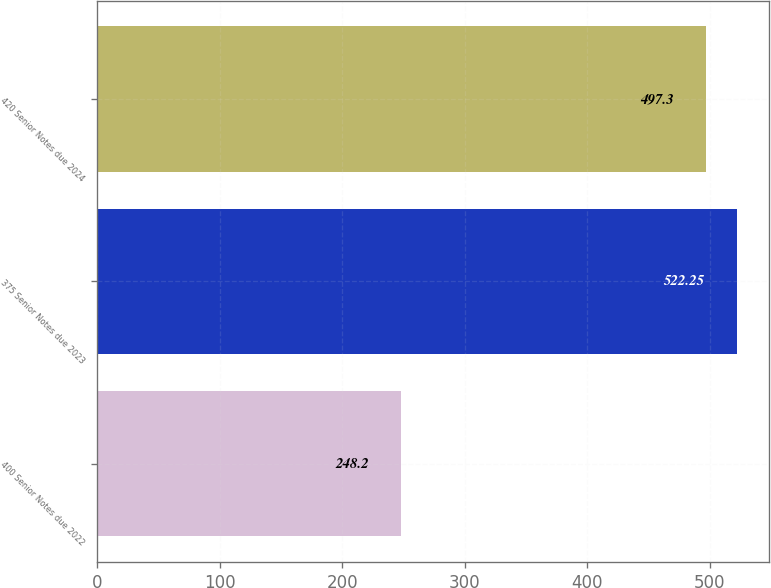<chart> <loc_0><loc_0><loc_500><loc_500><bar_chart><fcel>400 Senior Notes due 2022<fcel>375 Senior Notes due 2023<fcel>420 Senior Notes due 2024<nl><fcel>248.2<fcel>522.25<fcel>497.3<nl></chart> 